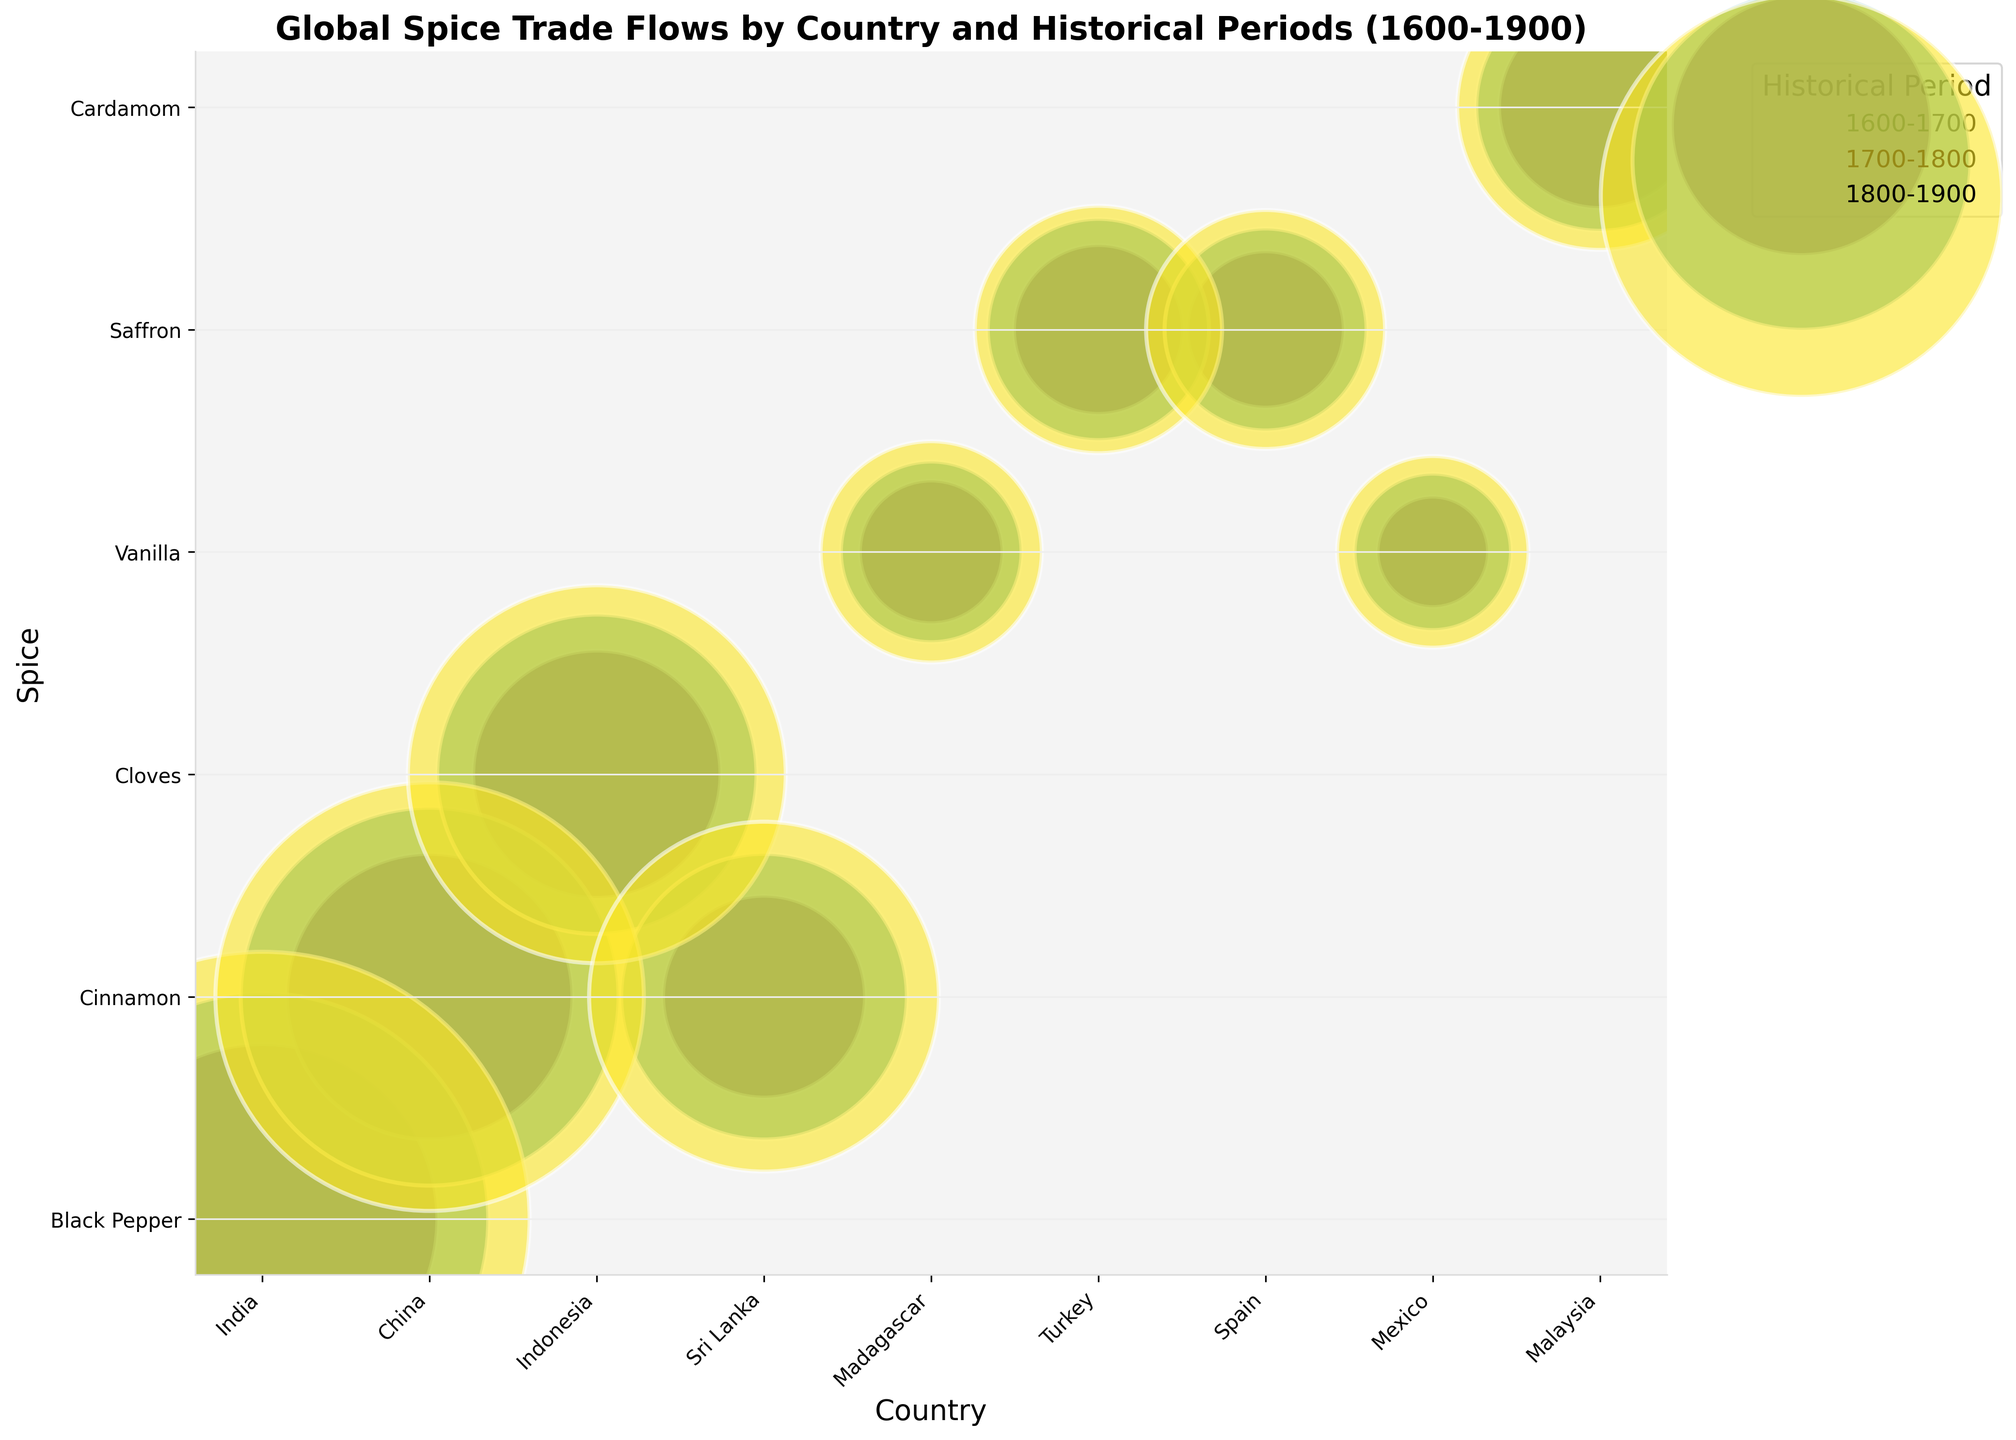What country had the highest trade value for Vanilla between 1600-1900? Comparing the trade values for Vanilla, Madagascar had a trade value of 0.5, 1.0, and 1.8 (millions USD) over three periods, and Mexico had a trade value of 0.4, 0.9, and 1.5 (millions USD). Madagascar had the highest value at 1.8 million USD in the 1800-1900 period.
Answer: Madagascar Which historical period shows the highest volume of Cardamom trade from Malaysia? For Malaysia, the volumes of Cardamom are 1000 tons (1600-1700), 1500 tons (1700-1800), and 2000 tons (1800-1900). Thus, the period with the highest volume is 1800-1900 with 2000 tons.
Answer: 1800-1900 Did India or China have a higher trade value for Cinnamon in 1800-1900? In the 1800-1900 period, China traded Cinnamon worth 2.5 million USD, while Sri Lanka also traded Cinnamon for 2.0 million USD. Therefore, China had the higher trade value for Cinnamon.
Answer: China Which country had the smallest bubble size in the 1600-1700 period, and what was the spice traded? The bubble size is calculated from the 'Volume (Metric Tons)' column. Madagascar had the smallest bubble with a volume of 500 tons for Vanilla in the 1600-1700 period.
Answer: Madagascar, Vanilla How does the volume of Black Pepper traded by India change over the periods 1600-1900? India's Black Pepper trade volumes are 3000 tons (1600-1700), 5000 tons (1700-1800), and 7000 tons (1800-1900). Hence, the trade volume increases progressively over these periods.
Answer: Increases Compare the trade value of Saffron between Turkey and Spain in the 1700-1800 period. Which country traded more? In the 1700-1800 period, Turkey traded Saffron worth 2.2 million USD, while Spain traded Saffron worth 1.8 million USD. Therefore, Turkey traded more Saffron in that period.
Answer: Turkey Which spice had the highest volume traded in the 1600-1700 period across all countries? By comparing the volumes, Black Pepper from India had the highest volume of 3000 tons in the 1600-1700 period.
Answer: Black Pepper What is the total trade value for Cloves from Indonesia across all periods? Summing the trade values for Cloves from Indonesia: 1.0 (1600-1700) + 1.5 (1700-1800) + 2.3 (1800-1900) = 4.8 million USD.
Answer: 4.8 million USD 